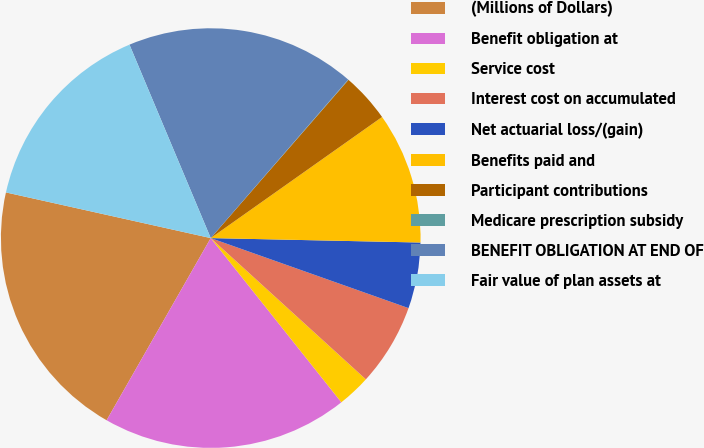Convert chart to OTSL. <chart><loc_0><loc_0><loc_500><loc_500><pie_chart><fcel>(Millions of Dollars)<fcel>Benefit obligation at<fcel>Service cost<fcel>Interest cost on accumulated<fcel>Net actuarial loss/(gain)<fcel>Benefits paid and<fcel>Participant contributions<fcel>Medicare prescription subsidy<fcel>BENEFIT OBLIGATION AT END OF<fcel>Fair value of plan assets at<nl><fcel>20.23%<fcel>18.96%<fcel>2.55%<fcel>6.34%<fcel>5.08%<fcel>10.13%<fcel>3.81%<fcel>0.03%<fcel>17.7%<fcel>15.18%<nl></chart> 